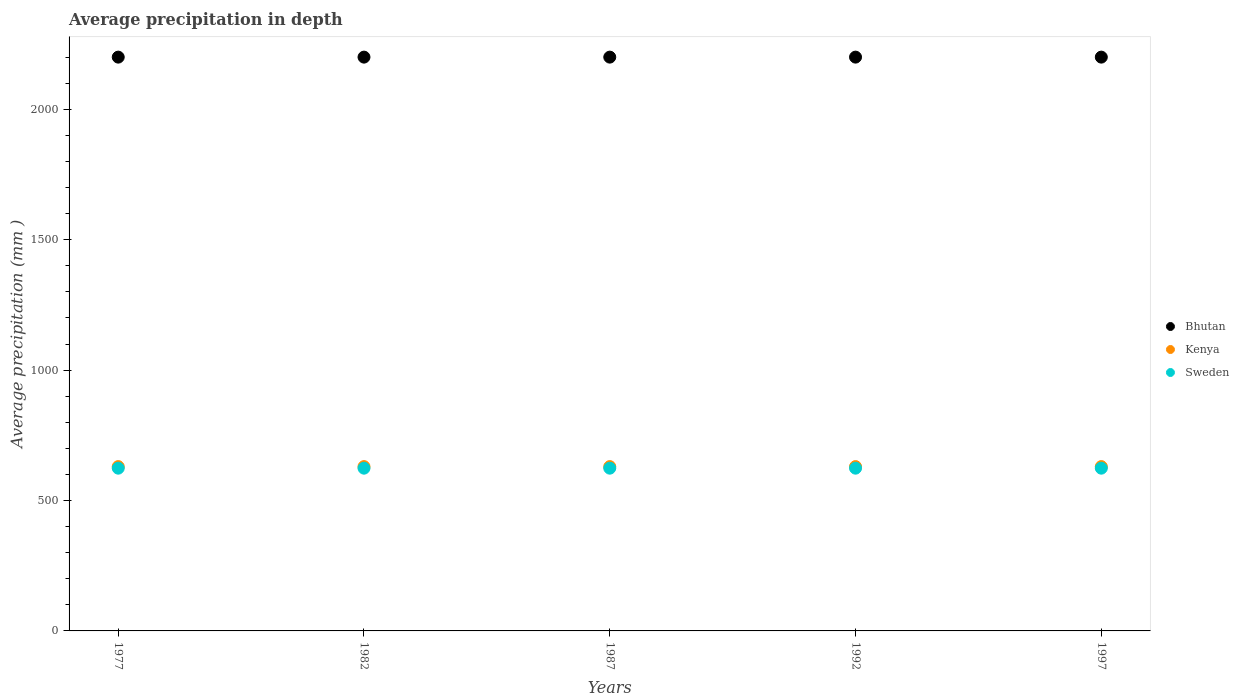How many different coloured dotlines are there?
Provide a succinct answer. 3. Is the number of dotlines equal to the number of legend labels?
Keep it short and to the point. Yes. What is the average precipitation in Bhutan in 1987?
Give a very brief answer. 2200. Across all years, what is the maximum average precipitation in Kenya?
Offer a very short reply. 630. Across all years, what is the minimum average precipitation in Kenya?
Ensure brevity in your answer.  630. In which year was the average precipitation in Bhutan maximum?
Make the answer very short. 1977. What is the total average precipitation in Sweden in the graph?
Offer a terse response. 3120. What is the difference between the average precipitation in Sweden in 1997 and the average precipitation in Bhutan in 1982?
Offer a terse response. -1576. What is the average average precipitation in Kenya per year?
Offer a very short reply. 630. In the year 1987, what is the difference between the average precipitation in Bhutan and average precipitation in Sweden?
Your answer should be very brief. 1576. What is the ratio of the average precipitation in Kenya in 1977 to that in 1992?
Make the answer very short. 1. Is the average precipitation in Kenya in 1987 less than that in 1997?
Your answer should be very brief. No. Is the difference between the average precipitation in Bhutan in 1977 and 1992 greater than the difference between the average precipitation in Sweden in 1977 and 1992?
Offer a very short reply. No. What is the difference between the highest and the second highest average precipitation in Sweden?
Your answer should be very brief. 0. What is the difference between the highest and the lowest average precipitation in Sweden?
Make the answer very short. 0. In how many years, is the average precipitation in Sweden greater than the average average precipitation in Sweden taken over all years?
Ensure brevity in your answer.  0. Is the sum of the average precipitation in Kenya in 1982 and 1992 greater than the maximum average precipitation in Bhutan across all years?
Ensure brevity in your answer.  No. Is it the case that in every year, the sum of the average precipitation in Kenya and average precipitation in Bhutan  is greater than the average precipitation in Sweden?
Provide a succinct answer. Yes. Does the average precipitation in Sweden monotonically increase over the years?
Provide a succinct answer. No. Is the average precipitation in Kenya strictly greater than the average precipitation in Sweden over the years?
Provide a succinct answer. Yes. How many dotlines are there?
Keep it short and to the point. 3. Are the values on the major ticks of Y-axis written in scientific E-notation?
Keep it short and to the point. No. Does the graph contain any zero values?
Your answer should be very brief. No. Does the graph contain grids?
Your answer should be very brief. No. How many legend labels are there?
Your response must be concise. 3. What is the title of the graph?
Provide a short and direct response. Average precipitation in depth. Does "Kazakhstan" appear as one of the legend labels in the graph?
Ensure brevity in your answer.  No. What is the label or title of the X-axis?
Ensure brevity in your answer.  Years. What is the label or title of the Y-axis?
Your response must be concise. Average precipitation (mm ). What is the Average precipitation (mm ) of Bhutan in 1977?
Your answer should be compact. 2200. What is the Average precipitation (mm ) of Kenya in 1977?
Your response must be concise. 630. What is the Average precipitation (mm ) in Sweden in 1977?
Your response must be concise. 624. What is the Average precipitation (mm ) in Bhutan in 1982?
Provide a short and direct response. 2200. What is the Average precipitation (mm ) of Kenya in 1982?
Your answer should be very brief. 630. What is the Average precipitation (mm ) of Sweden in 1982?
Offer a terse response. 624. What is the Average precipitation (mm ) in Bhutan in 1987?
Offer a terse response. 2200. What is the Average precipitation (mm ) of Kenya in 1987?
Keep it short and to the point. 630. What is the Average precipitation (mm ) in Sweden in 1987?
Your answer should be very brief. 624. What is the Average precipitation (mm ) of Bhutan in 1992?
Make the answer very short. 2200. What is the Average precipitation (mm ) in Kenya in 1992?
Give a very brief answer. 630. What is the Average precipitation (mm ) in Sweden in 1992?
Your answer should be compact. 624. What is the Average precipitation (mm ) of Bhutan in 1997?
Provide a succinct answer. 2200. What is the Average precipitation (mm ) in Kenya in 1997?
Your answer should be very brief. 630. What is the Average precipitation (mm ) of Sweden in 1997?
Provide a short and direct response. 624. Across all years, what is the maximum Average precipitation (mm ) of Bhutan?
Keep it short and to the point. 2200. Across all years, what is the maximum Average precipitation (mm ) in Kenya?
Provide a succinct answer. 630. Across all years, what is the maximum Average precipitation (mm ) in Sweden?
Provide a succinct answer. 624. Across all years, what is the minimum Average precipitation (mm ) in Bhutan?
Provide a succinct answer. 2200. Across all years, what is the minimum Average precipitation (mm ) in Kenya?
Offer a very short reply. 630. Across all years, what is the minimum Average precipitation (mm ) of Sweden?
Your answer should be very brief. 624. What is the total Average precipitation (mm ) of Bhutan in the graph?
Provide a succinct answer. 1.10e+04. What is the total Average precipitation (mm ) in Kenya in the graph?
Provide a short and direct response. 3150. What is the total Average precipitation (mm ) of Sweden in the graph?
Your answer should be very brief. 3120. What is the difference between the Average precipitation (mm ) of Bhutan in 1977 and that in 1982?
Ensure brevity in your answer.  0. What is the difference between the Average precipitation (mm ) in Kenya in 1977 and that in 1982?
Ensure brevity in your answer.  0. What is the difference between the Average precipitation (mm ) in Sweden in 1977 and that in 1982?
Your answer should be compact. 0. What is the difference between the Average precipitation (mm ) of Kenya in 1977 and that in 1987?
Your answer should be compact. 0. What is the difference between the Average precipitation (mm ) of Kenya in 1977 and that in 1992?
Your answer should be very brief. 0. What is the difference between the Average precipitation (mm ) in Sweden in 1977 and that in 1992?
Provide a succinct answer. 0. What is the difference between the Average precipitation (mm ) of Bhutan in 1977 and that in 1997?
Provide a short and direct response. 0. What is the difference between the Average precipitation (mm ) of Kenya in 1977 and that in 1997?
Your answer should be compact. 0. What is the difference between the Average precipitation (mm ) of Bhutan in 1982 and that in 1987?
Offer a very short reply. 0. What is the difference between the Average precipitation (mm ) in Bhutan in 1982 and that in 1992?
Offer a terse response. 0. What is the difference between the Average precipitation (mm ) in Kenya in 1982 and that in 1992?
Make the answer very short. 0. What is the difference between the Average precipitation (mm ) of Sweden in 1982 and that in 1992?
Offer a terse response. 0. What is the difference between the Average precipitation (mm ) of Kenya in 1982 and that in 1997?
Give a very brief answer. 0. What is the difference between the Average precipitation (mm ) of Sweden in 1982 and that in 1997?
Your answer should be compact. 0. What is the difference between the Average precipitation (mm ) of Kenya in 1987 and that in 1992?
Your answer should be compact. 0. What is the difference between the Average precipitation (mm ) of Bhutan in 1987 and that in 1997?
Offer a very short reply. 0. What is the difference between the Average precipitation (mm ) of Kenya in 1987 and that in 1997?
Provide a short and direct response. 0. What is the difference between the Average precipitation (mm ) of Bhutan in 1992 and that in 1997?
Make the answer very short. 0. What is the difference between the Average precipitation (mm ) of Kenya in 1992 and that in 1997?
Offer a terse response. 0. What is the difference between the Average precipitation (mm ) of Bhutan in 1977 and the Average precipitation (mm ) of Kenya in 1982?
Your answer should be compact. 1570. What is the difference between the Average precipitation (mm ) in Bhutan in 1977 and the Average precipitation (mm ) in Sweden in 1982?
Your answer should be very brief. 1576. What is the difference between the Average precipitation (mm ) in Kenya in 1977 and the Average precipitation (mm ) in Sweden in 1982?
Keep it short and to the point. 6. What is the difference between the Average precipitation (mm ) in Bhutan in 1977 and the Average precipitation (mm ) in Kenya in 1987?
Your answer should be compact. 1570. What is the difference between the Average precipitation (mm ) of Bhutan in 1977 and the Average precipitation (mm ) of Sweden in 1987?
Your response must be concise. 1576. What is the difference between the Average precipitation (mm ) in Bhutan in 1977 and the Average precipitation (mm ) in Kenya in 1992?
Provide a succinct answer. 1570. What is the difference between the Average precipitation (mm ) in Bhutan in 1977 and the Average precipitation (mm ) in Sweden in 1992?
Provide a succinct answer. 1576. What is the difference between the Average precipitation (mm ) of Kenya in 1977 and the Average precipitation (mm ) of Sweden in 1992?
Your answer should be compact. 6. What is the difference between the Average precipitation (mm ) of Bhutan in 1977 and the Average precipitation (mm ) of Kenya in 1997?
Provide a short and direct response. 1570. What is the difference between the Average precipitation (mm ) of Bhutan in 1977 and the Average precipitation (mm ) of Sweden in 1997?
Keep it short and to the point. 1576. What is the difference between the Average precipitation (mm ) of Kenya in 1977 and the Average precipitation (mm ) of Sweden in 1997?
Your response must be concise. 6. What is the difference between the Average precipitation (mm ) in Bhutan in 1982 and the Average precipitation (mm ) in Kenya in 1987?
Ensure brevity in your answer.  1570. What is the difference between the Average precipitation (mm ) of Bhutan in 1982 and the Average precipitation (mm ) of Sweden in 1987?
Keep it short and to the point. 1576. What is the difference between the Average precipitation (mm ) in Bhutan in 1982 and the Average precipitation (mm ) in Kenya in 1992?
Keep it short and to the point. 1570. What is the difference between the Average precipitation (mm ) in Bhutan in 1982 and the Average precipitation (mm ) in Sweden in 1992?
Give a very brief answer. 1576. What is the difference between the Average precipitation (mm ) in Kenya in 1982 and the Average precipitation (mm ) in Sweden in 1992?
Offer a very short reply. 6. What is the difference between the Average precipitation (mm ) of Bhutan in 1982 and the Average precipitation (mm ) of Kenya in 1997?
Provide a succinct answer. 1570. What is the difference between the Average precipitation (mm ) of Bhutan in 1982 and the Average precipitation (mm ) of Sweden in 1997?
Offer a terse response. 1576. What is the difference between the Average precipitation (mm ) in Bhutan in 1987 and the Average precipitation (mm ) in Kenya in 1992?
Provide a succinct answer. 1570. What is the difference between the Average precipitation (mm ) of Bhutan in 1987 and the Average precipitation (mm ) of Sweden in 1992?
Provide a succinct answer. 1576. What is the difference between the Average precipitation (mm ) of Kenya in 1987 and the Average precipitation (mm ) of Sweden in 1992?
Make the answer very short. 6. What is the difference between the Average precipitation (mm ) of Bhutan in 1987 and the Average precipitation (mm ) of Kenya in 1997?
Make the answer very short. 1570. What is the difference between the Average precipitation (mm ) in Bhutan in 1987 and the Average precipitation (mm ) in Sweden in 1997?
Your answer should be very brief. 1576. What is the difference between the Average precipitation (mm ) of Kenya in 1987 and the Average precipitation (mm ) of Sweden in 1997?
Provide a succinct answer. 6. What is the difference between the Average precipitation (mm ) of Bhutan in 1992 and the Average precipitation (mm ) of Kenya in 1997?
Provide a succinct answer. 1570. What is the difference between the Average precipitation (mm ) in Bhutan in 1992 and the Average precipitation (mm ) in Sweden in 1997?
Your response must be concise. 1576. What is the difference between the Average precipitation (mm ) in Kenya in 1992 and the Average precipitation (mm ) in Sweden in 1997?
Give a very brief answer. 6. What is the average Average precipitation (mm ) in Bhutan per year?
Offer a terse response. 2200. What is the average Average precipitation (mm ) of Kenya per year?
Your response must be concise. 630. What is the average Average precipitation (mm ) of Sweden per year?
Your answer should be compact. 624. In the year 1977, what is the difference between the Average precipitation (mm ) in Bhutan and Average precipitation (mm ) in Kenya?
Your answer should be compact. 1570. In the year 1977, what is the difference between the Average precipitation (mm ) of Bhutan and Average precipitation (mm ) of Sweden?
Provide a succinct answer. 1576. In the year 1982, what is the difference between the Average precipitation (mm ) in Bhutan and Average precipitation (mm ) in Kenya?
Keep it short and to the point. 1570. In the year 1982, what is the difference between the Average precipitation (mm ) of Bhutan and Average precipitation (mm ) of Sweden?
Provide a short and direct response. 1576. In the year 1987, what is the difference between the Average precipitation (mm ) in Bhutan and Average precipitation (mm ) in Kenya?
Give a very brief answer. 1570. In the year 1987, what is the difference between the Average precipitation (mm ) of Bhutan and Average precipitation (mm ) of Sweden?
Give a very brief answer. 1576. In the year 1987, what is the difference between the Average precipitation (mm ) in Kenya and Average precipitation (mm ) in Sweden?
Give a very brief answer. 6. In the year 1992, what is the difference between the Average precipitation (mm ) in Bhutan and Average precipitation (mm ) in Kenya?
Your answer should be very brief. 1570. In the year 1992, what is the difference between the Average precipitation (mm ) of Bhutan and Average precipitation (mm ) of Sweden?
Make the answer very short. 1576. In the year 1997, what is the difference between the Average precipitation (mm ) in Bhutan and Average precipitation (mm ) in Kenya?
Offer a very short reply. 1570. In the year 1997, what is the difference between the Average precipitation (mm ) in Bhutan and Average precipitation (mm ) in Sweden?
Your response must be concise. 1576. What is the ratio of the Average precipitation (mm ) in Kenya in 1977 to that in 1982?
Ensure brevity in your answer.  1. What is the ratio of the Average precipitation (mm ) of Bhutan in 1977 to that in 1987?
Provide a succinct answer. 1. What is the ratio of the Average precipitation (mm ) in Bhutan in 1977 to that in 1992?
Offer a very short reply. 1. What is the ratio of the Average precipitation (mm ) in Kenya in 1977 to that in 1997?
Your answer should be very brief. 1. What is the ratio of the Average precipitation (mm ) of Sweden in 1977 to that in 1997?
Give a very brief answer. 1. What is the ratio of the Average precipitation (mm ) in Bhutan in 1982 to that in 1987?
Ensure brevity in your answer.  1. What is the ratio of the Average precipitation (mm ) in Sweden in 1982 to that in 1987?
Keep it short and to the point. 1. What is the ratio of the Average precipitation (mm ) in Kenya in 1982 to that in 1992?
Provide a succinct answer. 1. What is the ratio of the Average precipitation (mm ) of Sweden in 1987 to that in 1997?
Provide a short and direct response. 1. What is the difference between the highest and the second highest Average precipitation (mm ) of Bhutan?
Provide a succinct answer. 0. What is the difference between the highest and the second highest Average precipitation (mm ) of Kenya?
Your response must be concise. 0. What is the difference between the highest and the second highest Average precipitation (mm ) of Sweden?
Offer a terse response. 0. What is the difference between the highest and the lowest Average precipitation (mm ) in Sweden?
Your answer should be very brief. 0. 